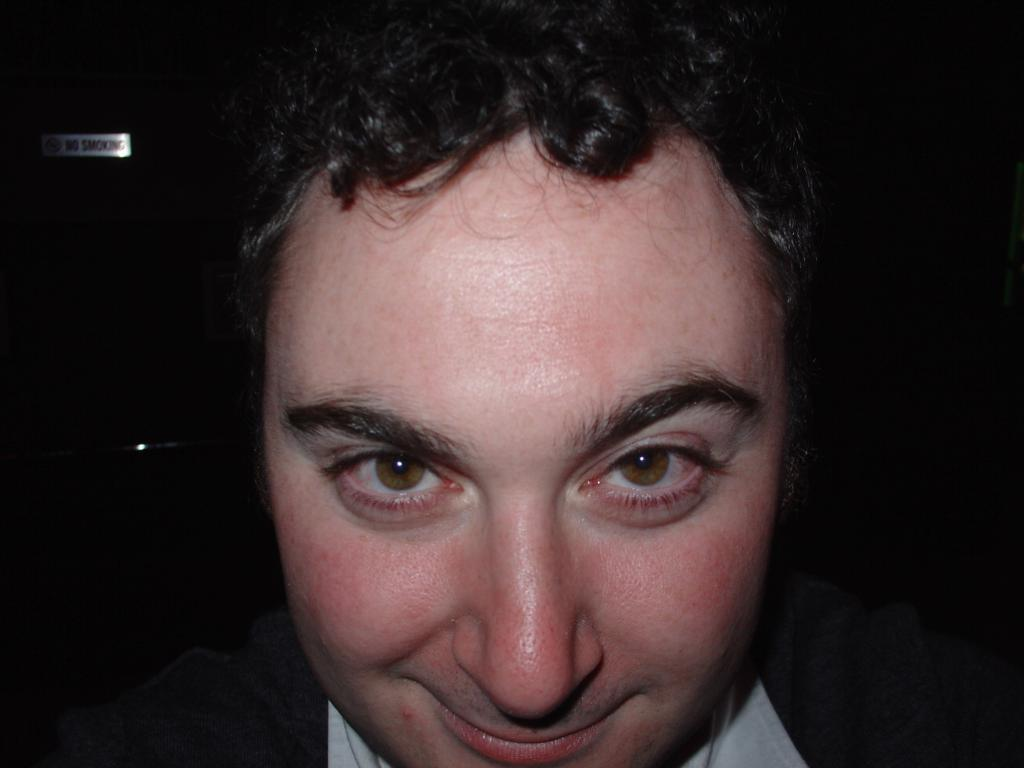What is the main subject in the foreground of the picture? There is a man in the foreground of the picture. What is the man's facial expression in the image? The man is smiling in the image. How would you describe the background of the image? The background of the image is dark. Can you identify any objects or structures in the background? Yes, there is a sign board with light focus in the background. How many frogs can be seen hopping on the man's shoulder in the image? There are no frogs present in the image, so it is not possible to determine how many might be hopping on the man's shoulder. 